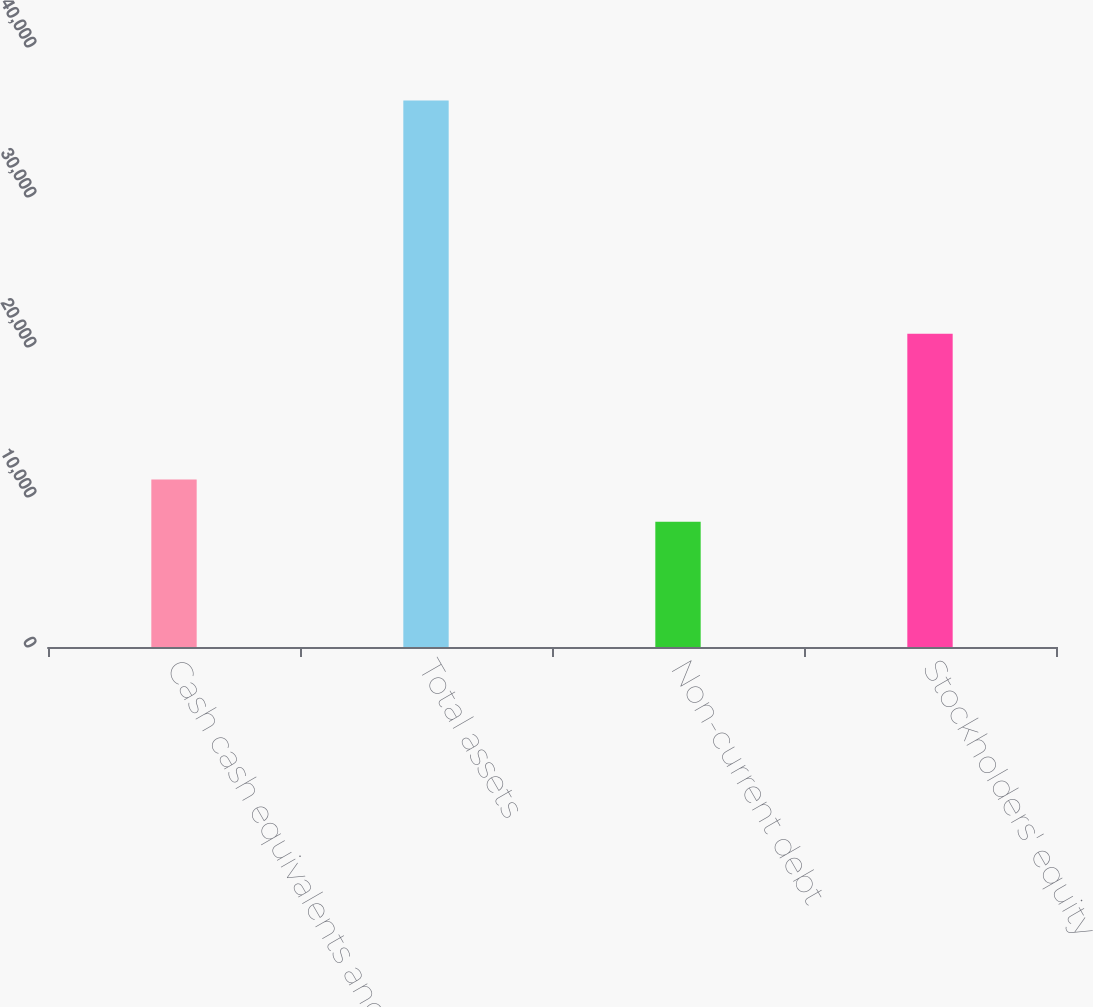Convert chart. <chart><loc_0><loc_0><loc_500><loc_500><bar_chart><fcel>Cash cash equivalents and<fcel>Total assets<fcel>Non-current debt<fcel>Stockholders' equity<nl><fcel>11159.5<fcel>36427<fcel>8352<fcel>20885<nl></chart> 